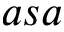<formula> <loc_0><loc_0><loc_500><loc_500>a s a</formula> 